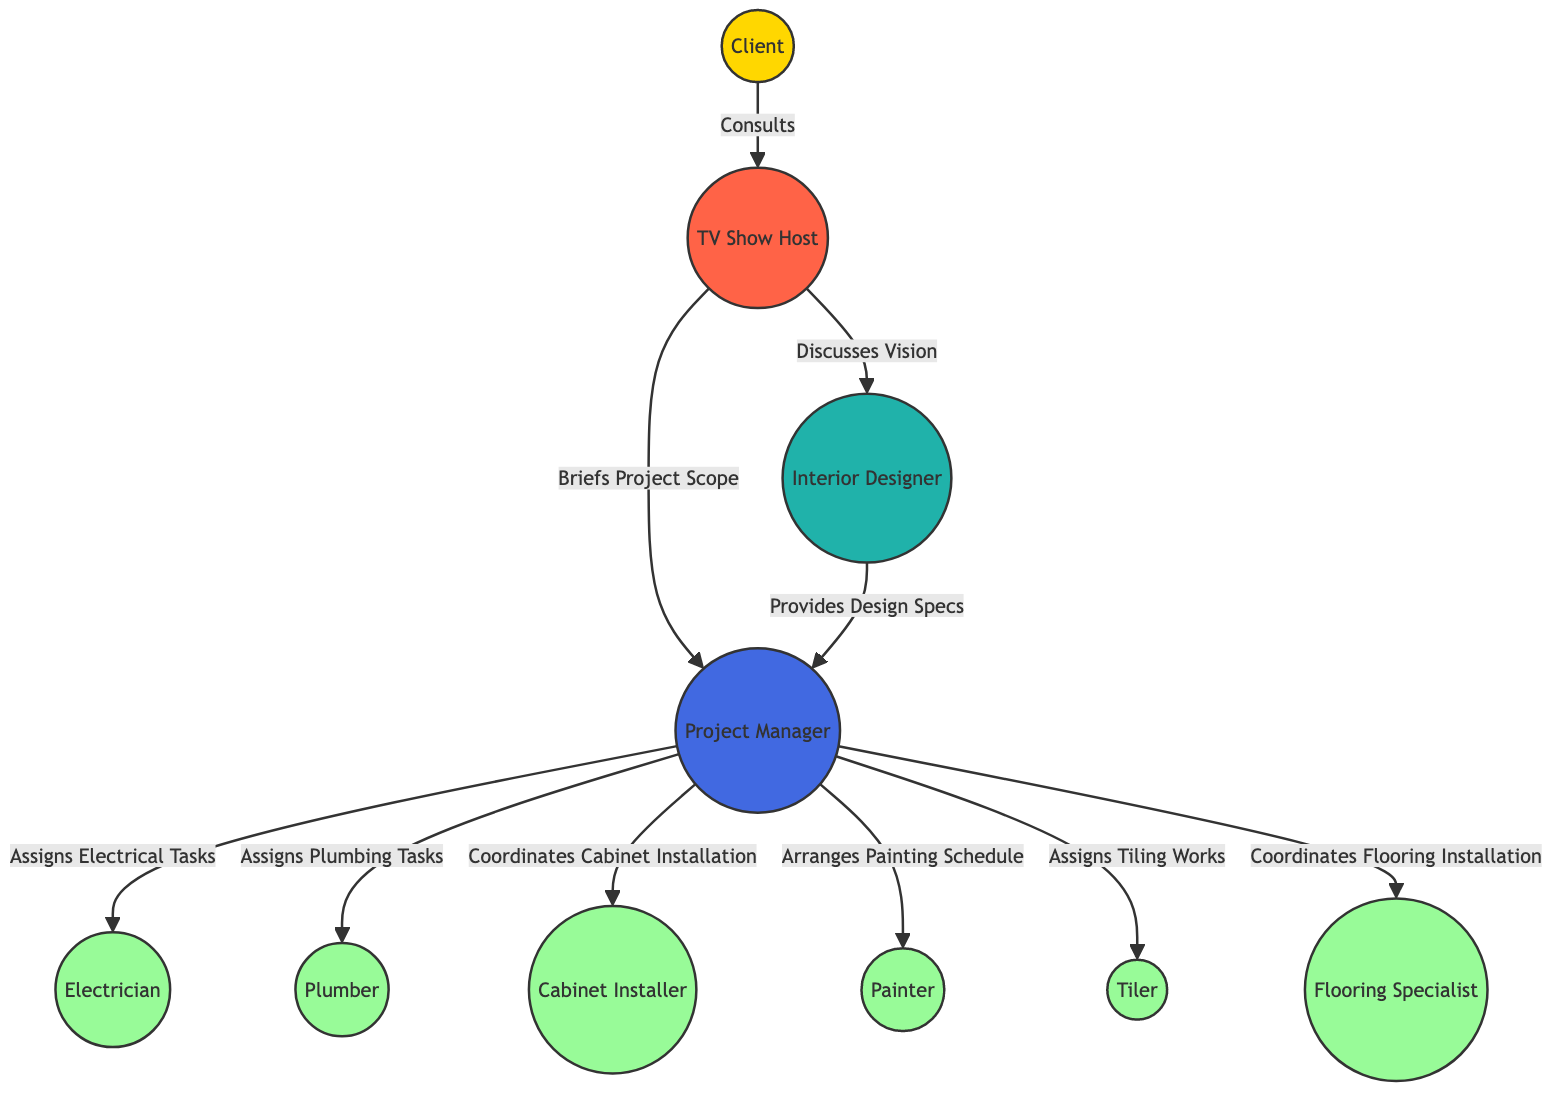What's the total number of nodes in the diagram? The diagram lists 10 entities involved in the kitchen remodel which are considered nodes, including the Client, TV Show Host, Interior Designer, Project Manager, Electrician, Plumber, Cabinet Installer, Painter, Tiler, and Flooring Specialist. Counting these gives us a total of 10 nodes.
Answer: 10 Which node is responsible for providing design specifications? In the diagram, the Designer node is linked to the Manager node with the label "Provides Design Specs", indicating that the Designer is responsible for this task.
Answer: Designer How many tasks are assigned by the Manager in the diagram? The Manager node has direct edges to six different worker nodes: Electrician, Plumber, Cabinet Installer, Painter, Tiler, and Flooring Specialist. This indicates that the Manager assigns a total of 6 tasks to different contractors.
Answer: 6 What is the relationship between the Host and the Designer? The diagram shows a directed edge from the Host node to the Designer node with the label "Discusses Vision", indicating that the Host shares or elaborates on the project vision with the Designer.
Answer: Discusses Vision Which worker is assigned to electrical tasks? Looking at the edge labeled "Assigns Electrical Tasks", it originates from the Manager node and points to the Electrician node, indicating that the Electrician is assigned to electrical tasks.
Answer: Electrician What is the starting node in the communication flow? The starting point of the communication flow is represented by the Client node, which initiates the process by consulting the Host.
Answer: Client How many edges are there in total connecting nodes in the diagram? The diagram contains 9 edges representing connections and tasks between nodes. Each edge signifies a specific relationship or assignment, totaling 9 connections.
Answer: 9 Which node does the Manager communicate with to arrange the painting schedule? The edge labeled "Arranges Painting Schedule" connects the Manager node to the Painter node, indicating that the Manager is the one who arranges the schedule with the Painter.
Answer: Painter Which two roles are directly involved in discussing the project vision? The edge labeled "Discusses Vision" directly connects the Host and the Designer, indicating that both the TV Show Host and the Interior Designer are involved in discussions about the project envisioning stage.
Answer: Host, Designer 